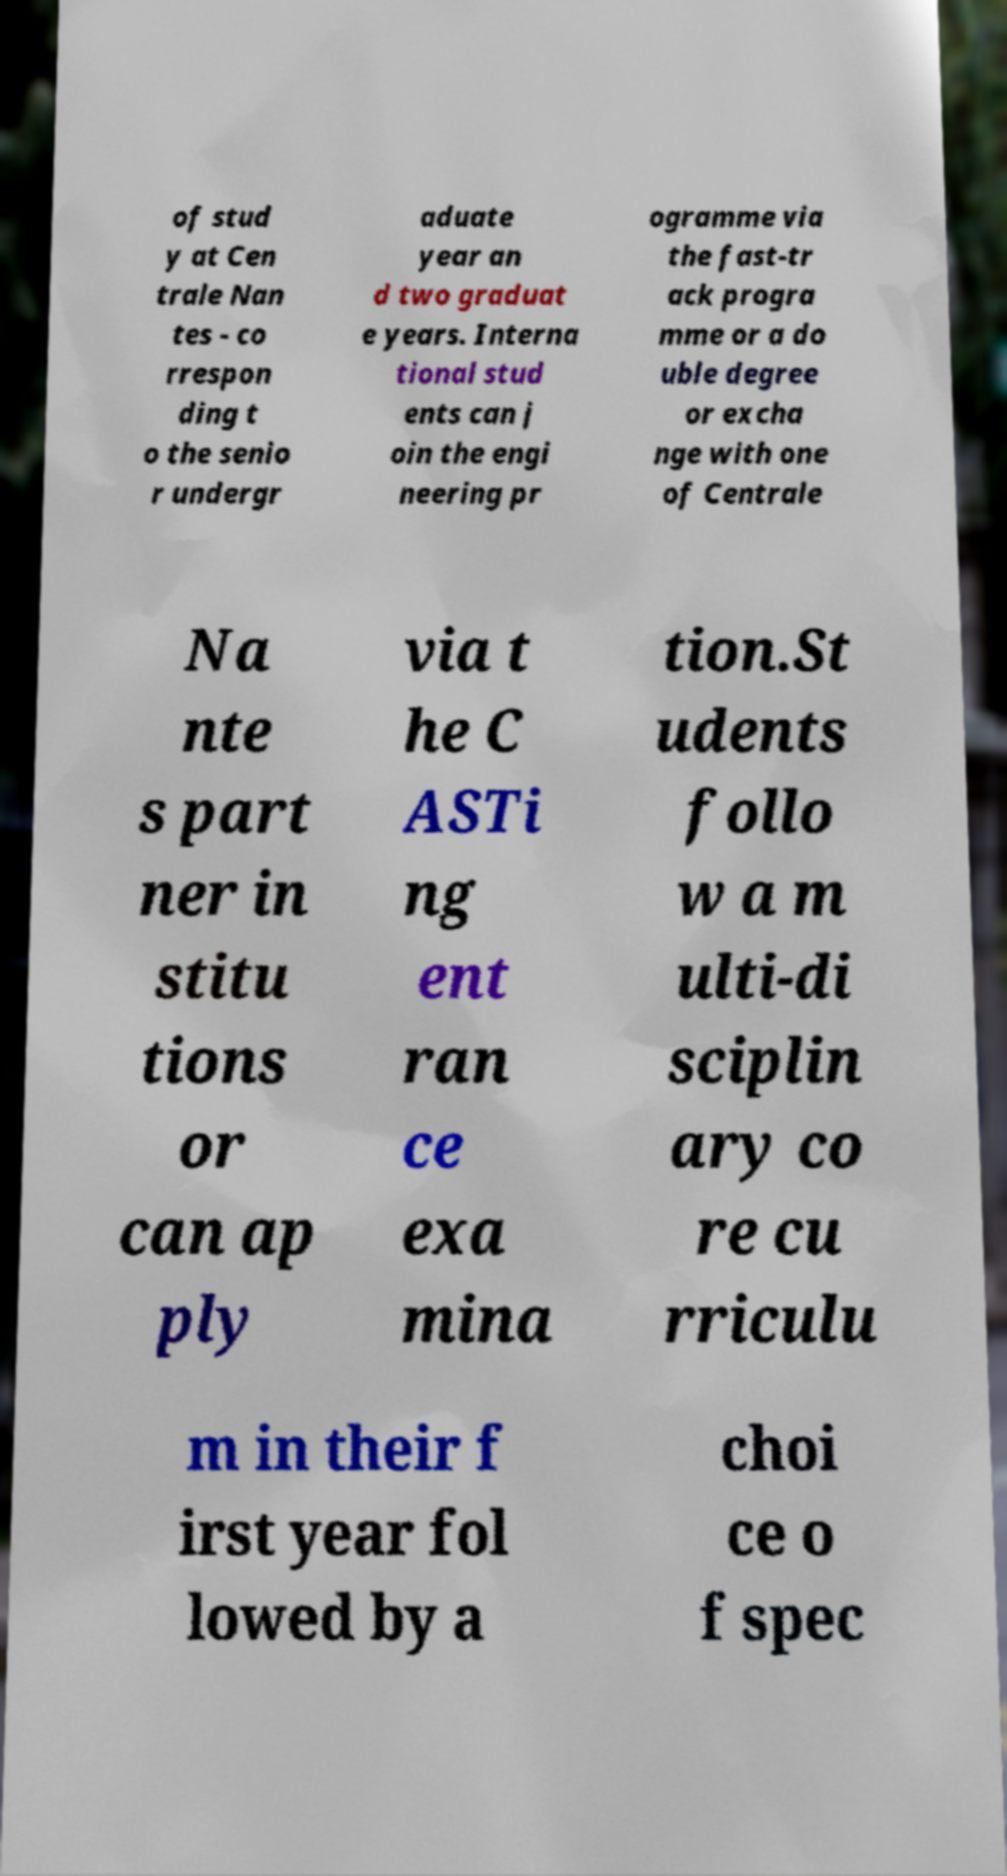I need the written content from this picture converted into text. Can you do that? of stud y at Cen trale Nan tes - co rrespon ding t o the senio r undergr aduate year an d two graduat e years. Interna tional stud ents can j oin the engi neering pr ogramme via the fast-tr ack progra mme or a do uble degree or excha nge with one of Centrale Na nte s part ner in stitu tions or can ap ply via t he C ASTi ng ent ran ce exa mina tion.St udents follo w a m ulti-di sciplin ary co re cu rriculu m in their f irst year fol lowed by a choi ce o f spec 